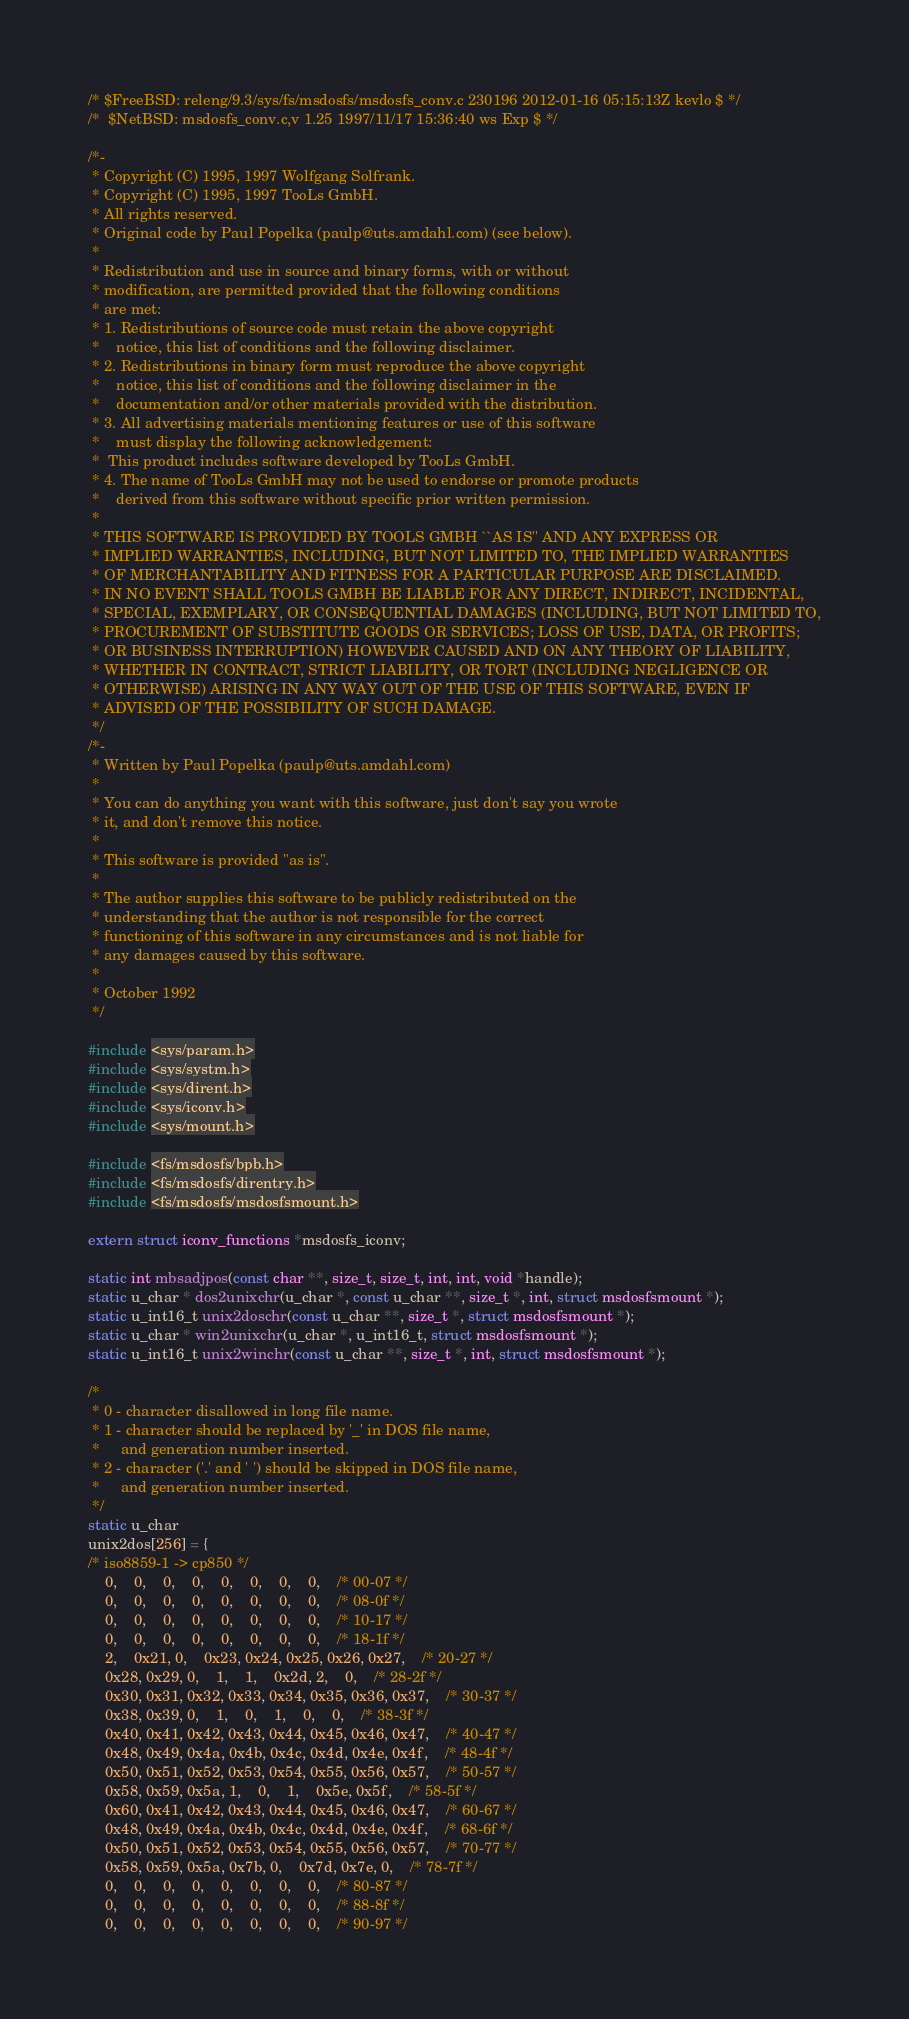<code> <loc_0><loc_0><loc_500><loc_500><_C_>/* $FreeBSD: releng/9.3/sys/fs/msdosfs/msdosfs_conv.c 230196 2012-01-16 05:15:13Z kevlo $ */
/*	$NetBSD: msdosfs_conv.c,v 1.25 1997/11/17 15:36:40 ws Exp $	*/

/*-
 * Copyright (C) 1995, 1997 Wolfgang Solfrank.
 * Copyright (C) 1995, 1997 TooLs GmbH.
 * All rights reserved.
 * Original code by Paul Popelka (paulp@uts.amdahl.com) (see below).
 *
 * Redistribution and use in source and binary forms, with or without
 * modification, are permitted provided that the following conditions
 * are met:
 * 1. Redistributions of source code must retain the above copyright
 *    notice, this list of conditions and the following disclaimer.
 * 2. Redistributions in binary form must reproduce the above copyright
 *    notice, this list of conditions and the following disclaimer in the
 *    documentation and/or other materials provided with the distribution.
 * 3. All advertising materials mentioning features or use of this software
 *    must display the following acknowledgement:
 *	This product includes software developed by TooLs GmbH.
 * 4. The name of TooLs GmbH may not be used to endorse or promote products
 *    derived from this software without specific prior written permission.
 *
 * THIS SOFTWARE IS PROVIDED BY TOOLS GMBH ``AS IS'' AND ANY EXPRESS OR
 * IMPLIED WARRANTIES, INCLUDING, BUT NOT LIMITED TO, THE IMPLIED WARRANTIES
 * OF MERCHANTABILITY AND FITNESS FOR A PARTICULAR PURPOSE ARE DISCLAIMED.
 * IN NO EVENT SHALL TOOLS GMBH BE LIABLE FOR ANY DIRECT, INDIRECT, INCIDENTAL,
 * SPECIAL, EXEMPLARY, OR CONSEQUENTIAL DAMAGES (INCLUDING, BUT NOT LIMITED TO,
 * PROCUREMENT OF SUBSTITUTE GOODS OR SERVICES; LOSS OF USE, DATA, OR PROFITS;
 * OR BUSINESS INTERRUPTION) HOWEVER CAUSED AND ON ANY THEORY OF LIABILITY,
 * WHETHER IN CONTRACT, STRICT LIABILITY, OR TORT (INCLUDING NEGLIGENCE OR
 * OTHERWISE) ARISING IN ANY WAY OUT OF THE USE OF THIS SOFTWARE, EVEN IF
 * ADVISED OF THE POSSIBILITY OF SUCH DAMAGE.
 */
/*-
 * Written by Paul Popelka (paulp@uts.amdahl.com)
 *
 * You can do anything you want with this software, just don't say you wrote
 * it, and don't remove this notice.
 *
 * This software is provided "as is".
 *
 * The author supplies this software to be publicly redistributed on the
 * understanding that the author is not responsible for the correct
 * functioning of this software in any circumstances and is not liable for
 * any damages caused by this software.
 *
 * October 1992
 */

#include <sys/param.h>
#include <sys/systm.h>
#include <sys/dirent.h>
#include <sys/iconv.h>
#include <sys/mount.h>

#include <fs/msdosfs/bpb.h>
#include <fs/msdosfs/direntry.h>
#include <fs/msdosfs/msdosfsmount.h>

extern struct iconv_functions *msdosfs_iconv;

static int mbsadjpos(const char **, size_t, size_t, int, int, void *handle);
static u_char * dos2unixchr(u_char *, const u_char **, size_t *, int, struct msdosfsmount *);
static u_int16_t unix2doschr(const u_char **, size_t *, struct msdosfsmount *);
static u_char * win2unixchr(u_char *, u_int16_t, struct msdosfsmount *);
static u_int16_t unix2winchr(const u_char **, size_t *, int, struct msdosfsmount *);

/*
 * 0 - character disallowed in long file name.
 * 1 - character should be replaced by '_' in DOS file name, 
 *     and generation number inserted.
 * 2 - character ('.' and ' ') should be skipped in DOS file name,
 *     and generation number inserted.
 */
static u_char
unix2dos[256] = {
/* iso8859-1 -> cp850 */
	0,    0,    0,    0,    0,    0,    0,    0,	/* 00-07 */
	0,    0,    0,    0,    0,    0,    0,    0,	/* 08-0f */
	0,    0,    0,    0,    0,    0,    0,    0,	/* 10-17 */
	0,    0,    0,    0,    0,    0,    0,    0,	/* 18-1f */
	2,    0x21, 0,    0x23, 0x24, 0x25, 0x26, 0x27,	/* 20-27 */
	0x28, 0x29, 0,    1,    1,    0x2d, 2,    0,	/* 28-2f */
	0x30, 0x31, 0x32, 0x33, 0x34, 0x35, 0x36, 0x37,	/* 30-37 */
	0x38, 0x39, 0,    1,    0,    1,    0,    0,	/* 38-3f */
	0x40, 0x41, 0x42, 0x43, 0x44, 0x45, 0x46, 0x47,	/* 40-47 */
	0x48, 0x49, 0x4a, 0x4b, 0x4c, 0x4d, 0x4e, 0x4f,	/* 48-4f */
	0x50, 0x51, 0x52, 0x53, 0x54, 0x55, 0x56, 0x57,	/* 50-57 */
	0x58, 0x59, 0x5a, 1,    0,    1,    0x5e, 0x5f,	/* 58-5f */
	0x60, 0x41, 0x42, 0x43, 0x44, 0x45, 0x46, 0x47,	/* 60-67 */
	0x48, 0x49, 0x4a, 0x4b, 0x4c, 0x4d, 0x4e, 0x4f,	/* 68-6f */
	0x50, 0x51, 0x52, 0x53, 0x54, 0x55, 0x56, 0x57,	/* 70-77 */
	0x58, 0x59, 0x5a, 0x7b, 0,    0x7d, 0x7e, 0,	/* 78-7f */
	0,    0,    0,    0,    0,    0,    0,    0,	/* 80-87 */
	0,    0,    0,    0,    0,    0,    0,    0,	/* 88-8f */
	0,    0,    0,    0,    0,    0,    0,    0,	/* 90-97 */</code> 